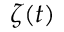<formula> <loc_0><loc_0><loc_500><loc_500>\zeta ( t )</formula> 